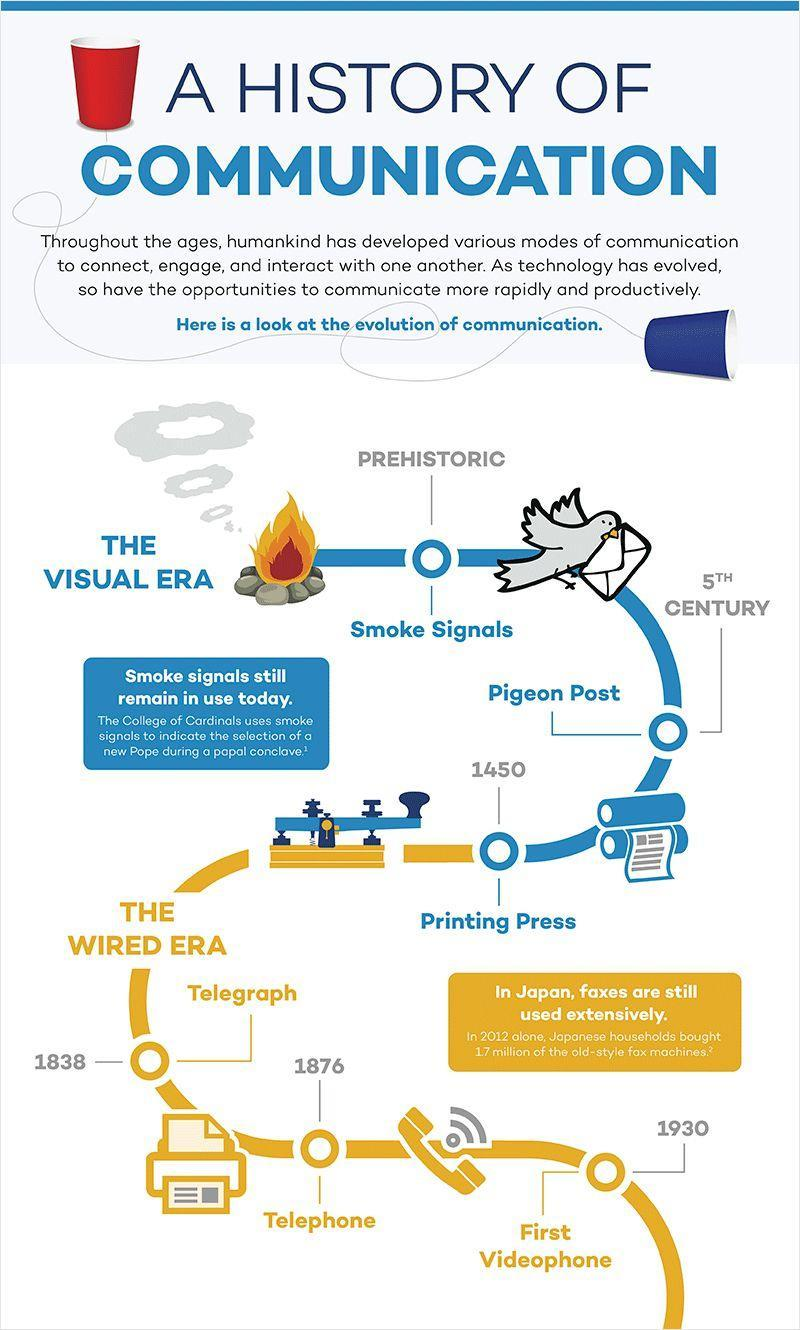The Telegraph was invented in which year?
Answer the question with a short phrase. 1838 The Telephone was invented in which year? 1876 